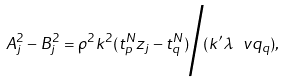<formula> <loc_0><loc_0><loc_500><loc_500>A _ { j } ^ { 2 } - B _ { j } ^ { 2 } = \rho ^ { 2 } k ^ { 2 } ( t _ { p } ^ { N } z _ { j } - t _ { q } ^ { N } ) \Big / ( k ^ { \prime } \lambda \ v q _ { q } ) ,</formula> 